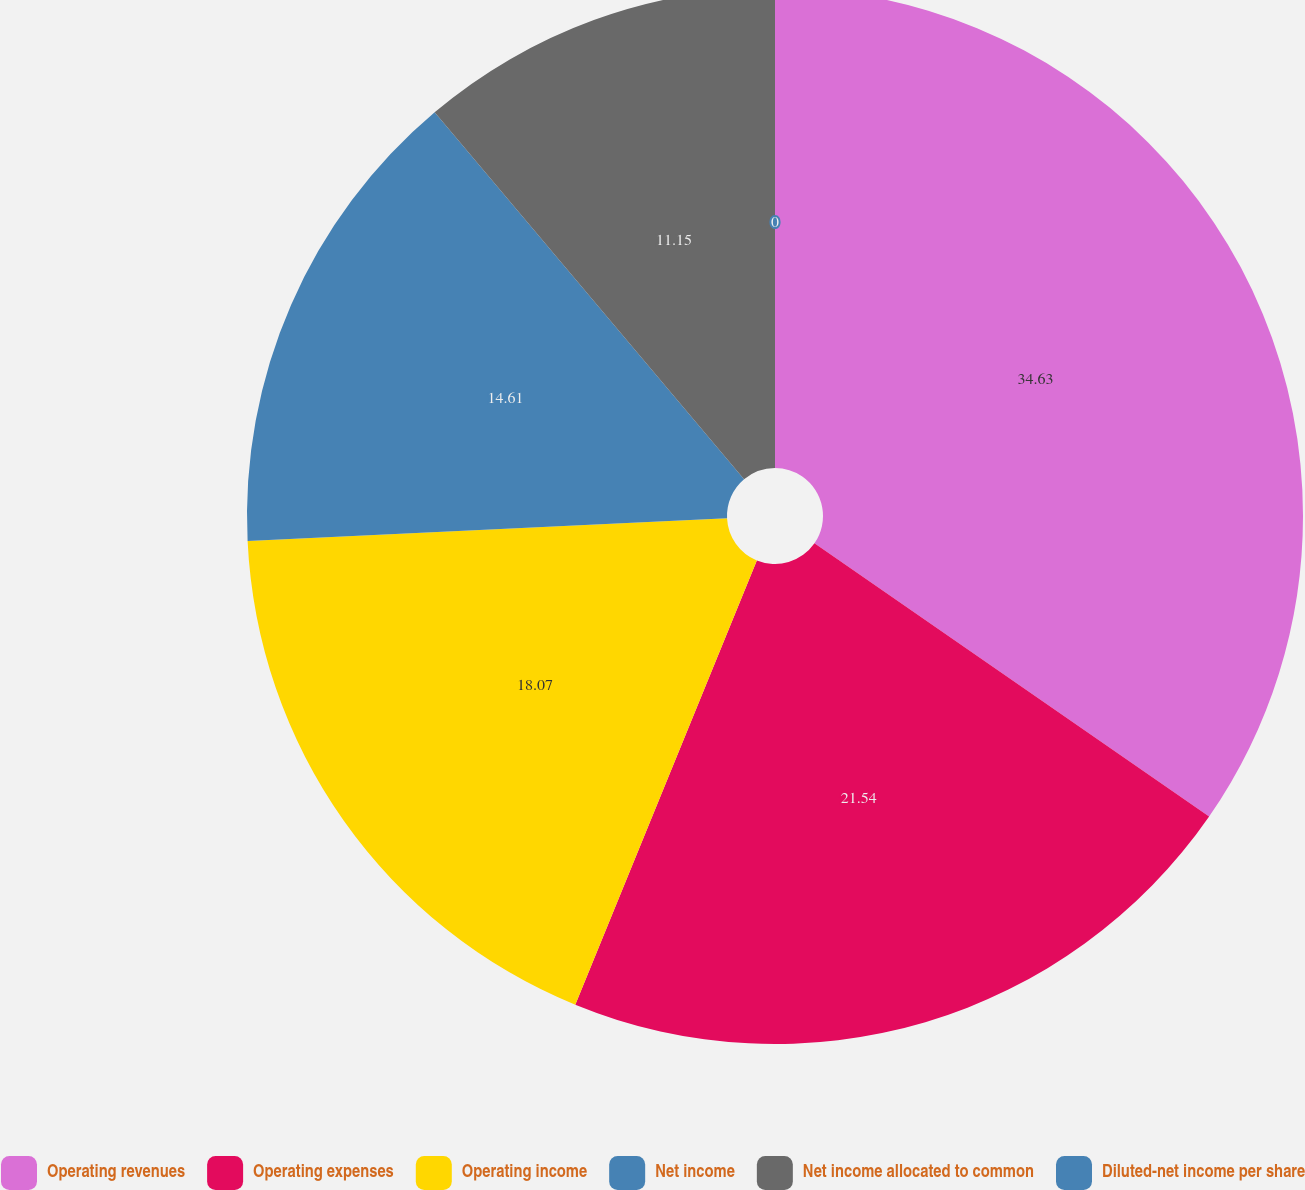Convert chart. <chart><loc_0><loc_0><loc_500><loc_500><pie_chart><fcel>Operating revenues<fcel>Operating expenses<fcel>Operating income<fcel>Net income<fcel>Net income allocated to common<fcel>Diluted-net income per share<nl><fcel>34.64%<fcel>21.54%<fcel>18.07%<fcel>14.61%<fcel>11.15%<fcel>0.0%<nl></chart> 